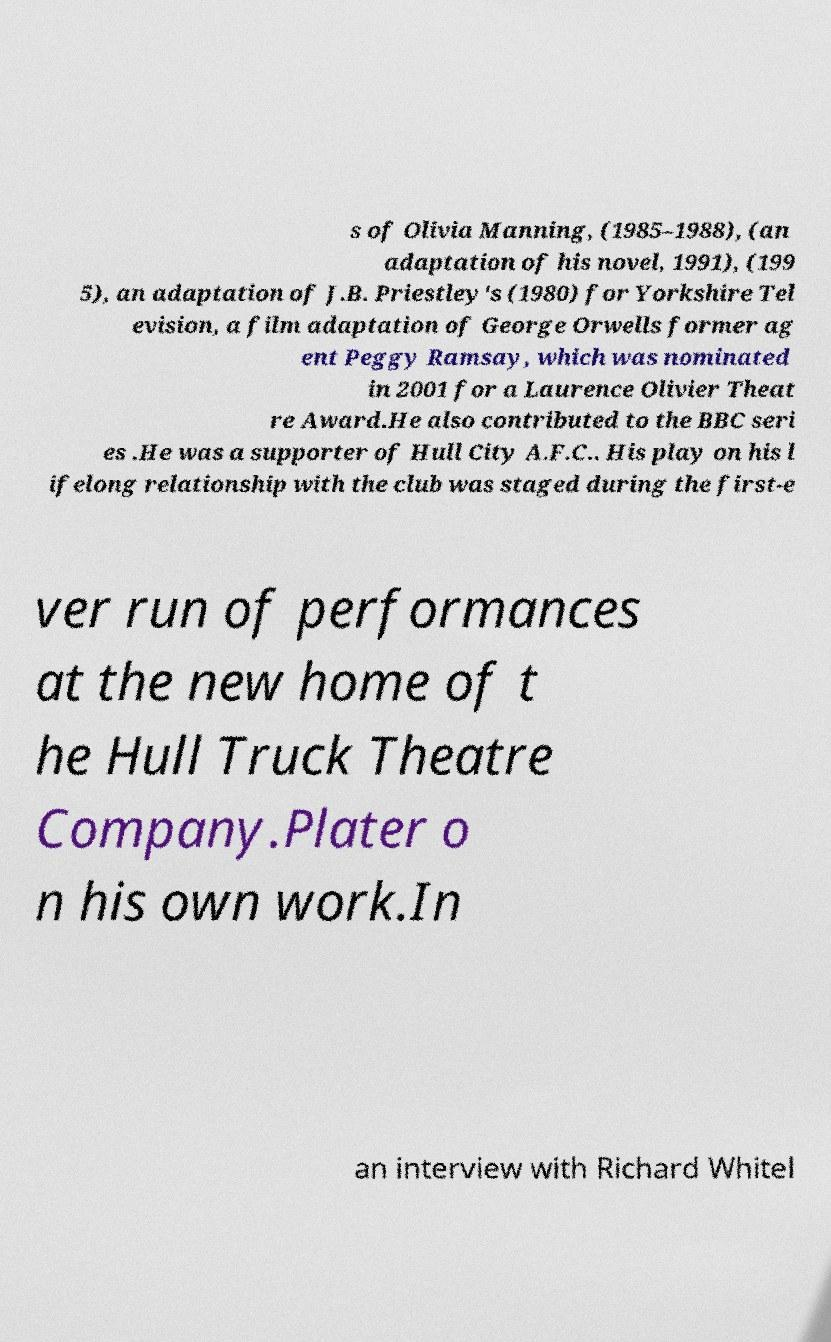What messages or text are displayed in this image? I need them in a readable, typed format. s of Olivia Manning, (1985–1988), (an adaptation of his novel, 1991), (199 5), an adaptation of J.B. Priestley's (1980) for Yorkshire Tel evision, a film adaptation of George Orwells former ag ent Peggy Ramsay, which was nominated in 2001 for a Laurence Olivier Theat re Award.He also contributed to the BBC seri es .He was a supporter of Hull City A.F.C.. His play on his l ifelong relationship with the club was staged during the first-e ver run of performances at the new home of t he Hull Truck Theatre Company.Plater o n his own work.In an interview with Richard Whitel 